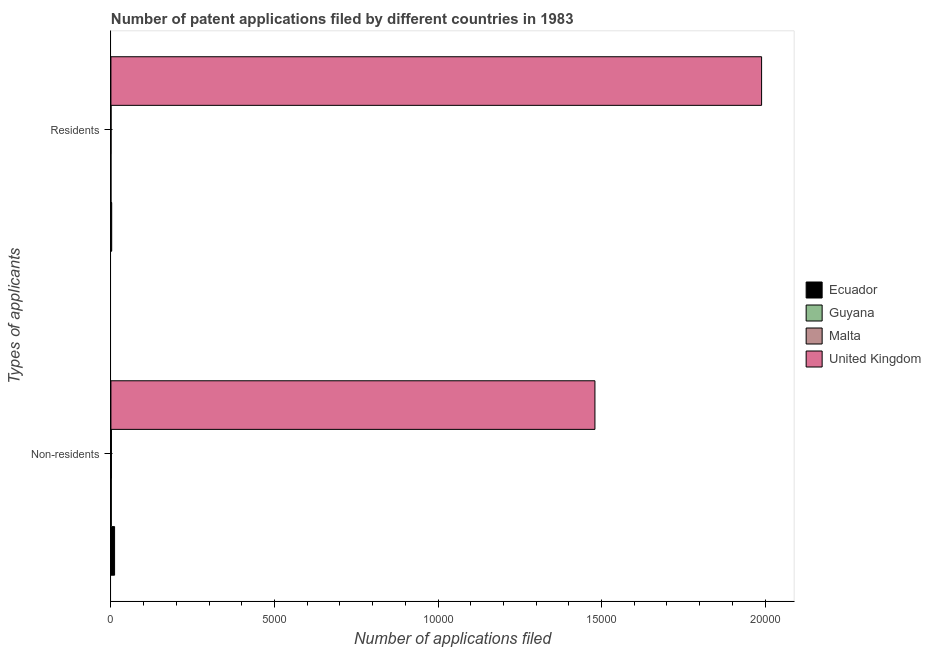How many different coloured bars are there?
Offer a terse response. 4. How many groups of bars are there?
Ensure brevity in your answer.  2. How many bars are there on the 2nd tick from the bottom?
Your response must be concise. 4. What is the label of the 1st group of bars from the top?
Offer a terse response. Residents. What is the number of patent applications by residents in United Kingdom?
Provide a short and direct response. 1.99e+04. Across all countries, what is the maximum number of patent applications by residents?
Your answer should be very brief. 1.99e+04. Across all countries, what is the minimum number of patent applications by residents?
Provide a succinct answer. 1. In which country was the number of patent applications by residents maximum?
Provide a short and direct response. United Kingdom. In which country was the number of patent applications by non residents minimum?
Offer a very short reply. Guyana. What is the total number of patent applications by residents in the graph?
Provide a short and direct response. 1.99e+04. What is the difference between the number of patent applications by residents in Guyana and that in Ecuador?
Offer a terse response. -23. What is the difference between the number of patent applications by residents in Malta and the number of patent applications by non residents in United Kingdom?
Your answer should be very brief. -1.48e+04. What is the average number of patent applications by non residents per country?
Keep it short and to the point. 3734.5. What is the difference between the number of patent applications by non residents and number of patent applications by residents in Malta?
Provide a short and direct response. 12. In how many countries, is the number of patent applications by residents greater than 10000 ?
Provide a short and direct response. 1. What is the ratio of the number of patent applications by residents in Ecuador to that in United Kingdom?
Offer a terse response. 0. Is the number of patent applications by residents in Guyana less than that in Ecuador?
Offer a very short reply. Yes. In how many countries, is the number of patent applications by residents greater than the average number of patent applications by residents taken over all countries?
Your answer should be very brief. 1. What does the 3rd bar from the top in Non-residents represents?
Your answer should be compact. Guyana. What does the 1st bar from the bottom in Non-residents represents?
Offer a very short reply. Ecuador. How many bars are there?
Offer a very short reply. 8. Does the graph contain any zero values?
Your answer should be compact. No. How many legend labels are there?
Your response must be concise. 4. What is the title of the graph?
Make the answer very short. Number of patent applications filed by different countries in 1983. What is the label or title of the X-axis?
Provide a succinct answer. Number of applications filed. What is the label or title of the Y-axis?
Your answer should be compact. Types of applicants. What is the Number of applications filed of Ecuador in Non-residents?
Provide a short and direct response. 112. What is the Number of applications filed of Malta in Non-residents?
Make the answer very short. 16. What is the Number of applications filed of United Kingdom in Non-residents?
Give a very brief answer. 1.48e+04. What is the Number of applications filed in Ecuador in Residents?
Offer a terse response. 24. What is the Number of applications filed in Guyana in Residents?
Your answer should be very brief. 1. What is the Number of applications filed in United Kingdom in Residents?
Give a very brief answer. 1.99e+04. Across all Types of applicants, what is the maximum Number of applications filed of Ecuador?
Provide a succinct answer. 112. Across all Types of applicants, what is the maximum Number of applications filed in Malta?
Your answer should be very brief. 16. Across all Types of applicants, what is the maximum Number of applications filed of United Kingdom?
Your answer should be very brief. 1.99e+04. Across all Types of applicants, what is the minimum Number of applications filed in Ecuador?
Make the answer very short. 24. Across all Types of applicants, what is the minimum Number of applications filed of United Kingdom?
Provide a succinct answer. 1.48e+04. What is the total Number of applications filed of Ecuador in the graph?
Keep it short and to the point. 136. What is the total Number of applications filed of Guyana in the graph?
Ensure brevity in your answer.  13. What is the total Number of applications filed of United Kingdom in the graph?
Keep it short and to the point. 3.47e+04. What is the difference between the Number of applications filed in Guyana in Non-residents and that in Residents?
Provide a succinct answer. 11. What is the difference between the Number of applications filed of United Kingdom in Non-residents and that in Residents?
Give a very brief answer. -5095. What is the difference between the Number of applications filed in Ecuador in Non-residents and the Number of applications filed in Guyana in Residents?
Offer a very short reply. 111. What is the difference between the Number of applications filed in Ecuador in Non-residents and the Number of applications filed in Malta in Residents?
Provide a short and direct response. 108. What is the difference between the Number of applications filed of Ecuador in Non-residents and the Number of applications filed of United Kingdom in Residents?
Offer a very short reply. -1.98e+04. What is the difference between the Number of applications filed in Guyana in Non-residents and the Number of applications filed in United Kingdom in Residents?
Give a very brief answer. -1.99e+04. What is the difference between the Number of applications filed in Malta in Non-residents and the Number of applications filed in United Kingdom in Residents?
Ensure brevity in your answer.  -1.99e+04. What is the average Number of applications filed of United Kingdom per Types of applicants?
Provide a succinct answer. 1.73e+04. What is the difference between the Number of applications filed in Ecuador and Number of applications filed in Malta in Non-residents?
Give a very brief answer. 96. What is the difference between the Number of applications filed in Ecuador and Number of applications filed in United Kingdom in Non-residents?
Offer a very short reply. -1.47e+04. What is the difference between the Number of applications filed in Guyana and Number of applications filed in Malta in Non-residents?
Offer a terse response. -4. What is the difference between the Number of applications filed of Guyana and Number of applications filed of United Kingdom in Non-residents?
Your answer should be very brief. -1.48e+04. What is the difference between the Number of applications filed of Malta and Number of applications filed of United Kingdom in Non-residents?
Ensure brevity in your answer.  -1.48e+04. What is the difference between the Number of applications filed in Ecuador and Number of applications filed in United Kingdom in Residents?
Your response must be concise. -1.99e+04. What is the difference between the Number of applications filed in Guyana and Number of applications filed in Malta in Residents?
Offer a very short reply. -3. What is the difference between the Number of applications filed in Guyana and Number of applications filed in United Kingdom in Residents?
Offer a very short reply. -1.99e+04. What is the difference between the Number of applications filed of Malta and Number of applications filed of United Kingdom in Residents?
Your response must be concise. -1.99e+04. What is the ratio of the Number of applications filed in Ecuador in Non-residents to that in Residents?
Your answer should be very brief. 4.67. What is the ratio of the Number of applications filed in Malta in Non-residents to that in Residents?
Give a very brief answer. 4. What is the ratio of the Number of applications filed of United Kingdom in Non-residents to that in Residents?
Give a very brief answer. 0.74. What is the difference between the highest and the second highest Number of applications filed of Ecuador?
Your answer should be compact. 88. What is the difference between the highest and the second highest Number of applications filed in Malta?
Your answer should be compact. 12. What is the difference between the highest and the second highest Number of applications filed in United Kingdom?
Ensure brevity in your answer.  5095. What is the difference between the highest and the lowest Number of applications filed of United Kingdom?
Ensure brevity in your answer.  5095. 